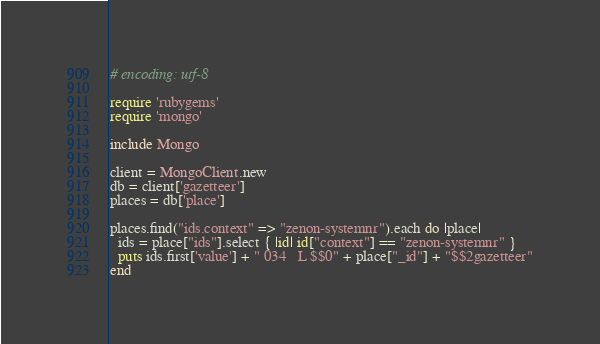<code> <loc_0><loc_0><loc_500><loc_500><_Ruby_># encoding: utf-8

require 'rubygems'
require 'mongo'

include Mongo

client = MongoClient.new
db = client['gazetteer']
places = db['place']

places.find("ids.context" => "zenon-systemnr").each do |place|
  ids = place["ids"].select { |id| id["context"] == "zenon-systemnr" }
  puts ids.first['value'] + " 034   L $$0" + place["_id"] + "$$2gazetteer"
end</code> 